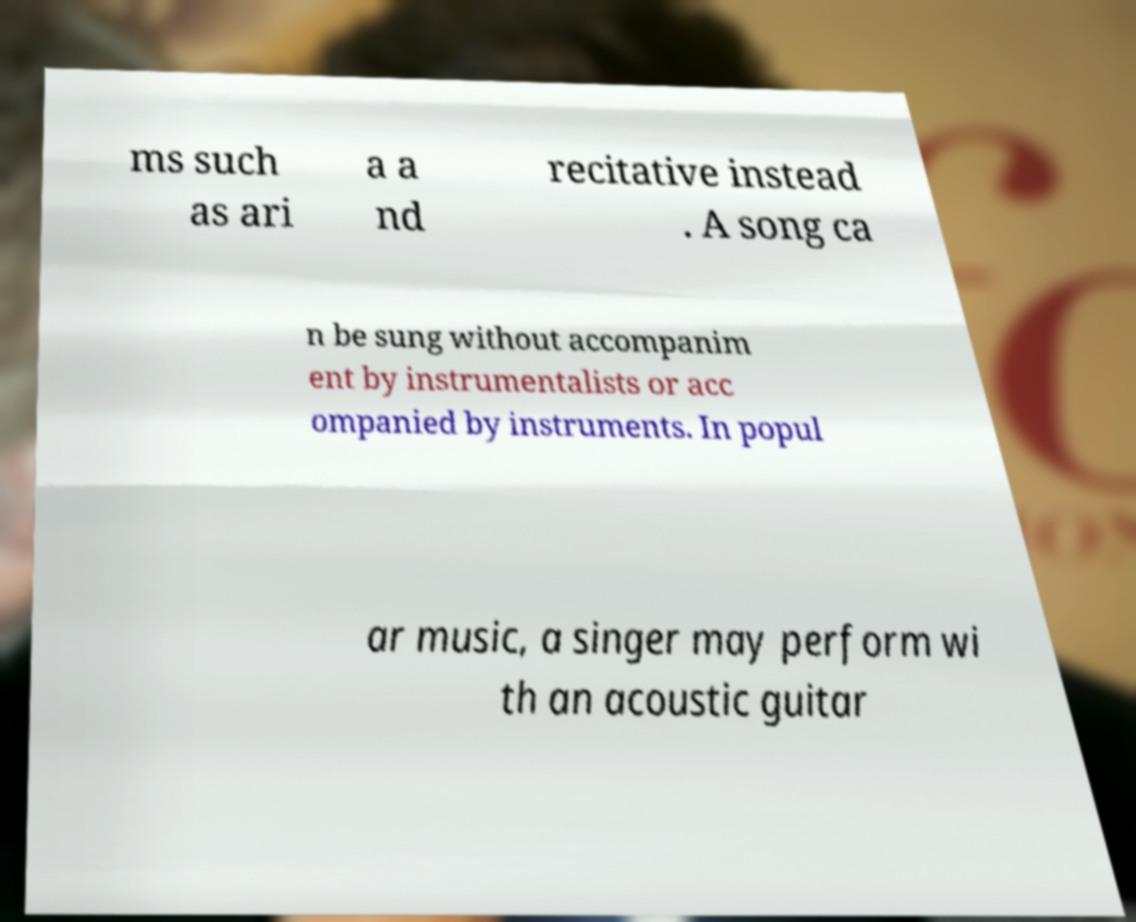Can you accurately transcribe the text from the provided image for me? ms such as ari a a nd recitative instead . A song ca n be sung without accompanim ent by instrumentalists or acc ompanied by instruments. In popul ar music, a singer may perform wi th an acoustic guitar 